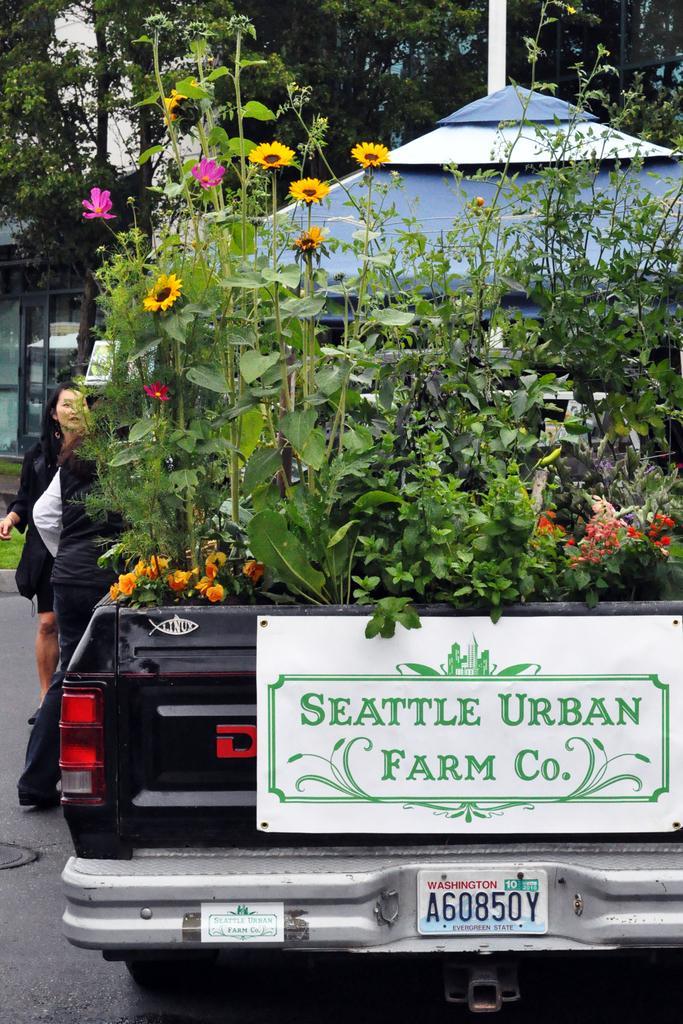Please provide a concise description of this image. In the center of the image we can see trees and plants placed in the vehicle. On the left side of the image we can see person on the road. In the background we can see tent, buildings, trees and sky. 